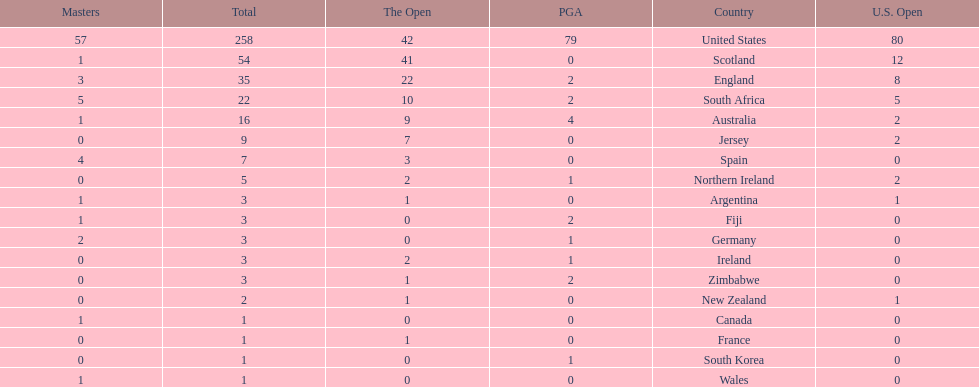How many countries have produced the same number of championship golfers as canada? 3. 